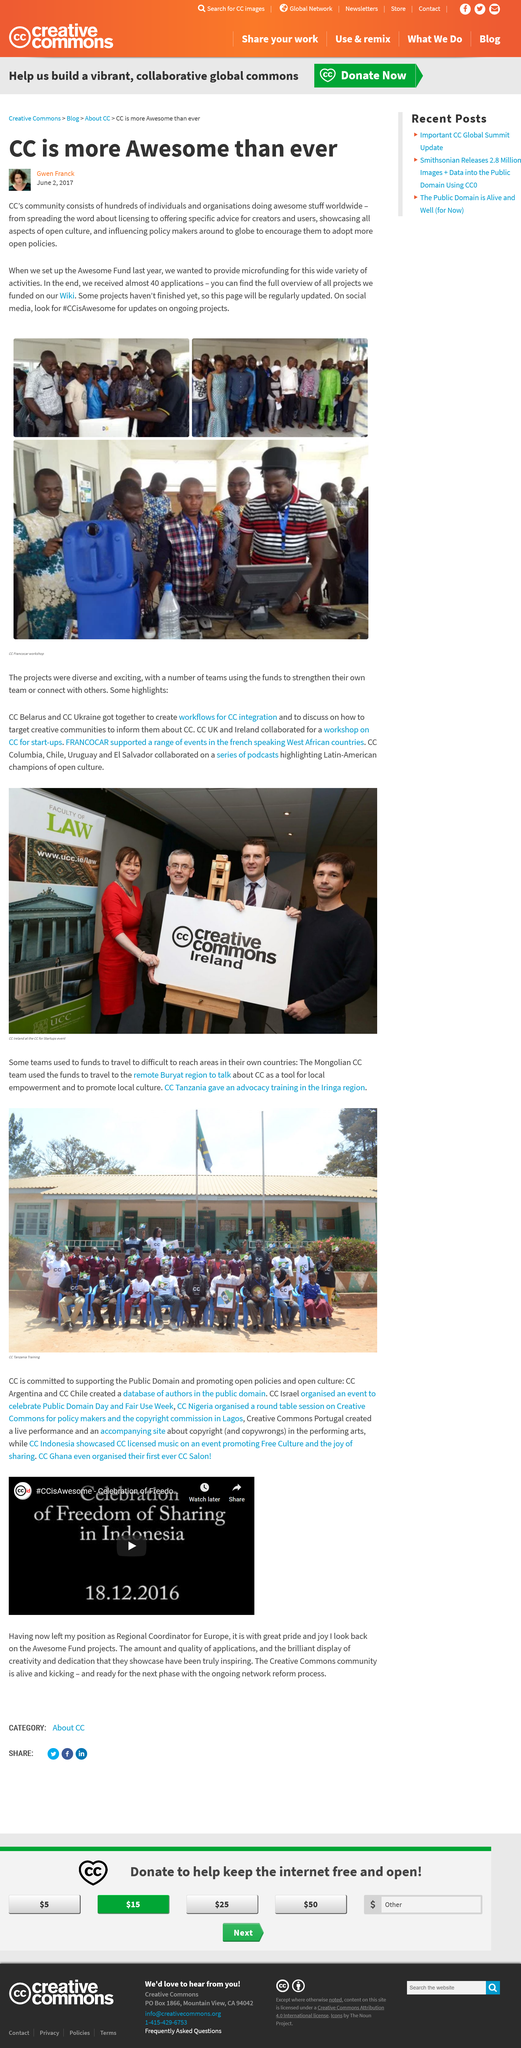Mention a couple of crucial points in this snapshot. CC plans to fund its projects and activities with the Awesome Fund. In the images, some of the people appear to be looking at something. Two of the people are specifically looking at a computer. CC opened the Awesome Fund to provide microfunding for their activities. 